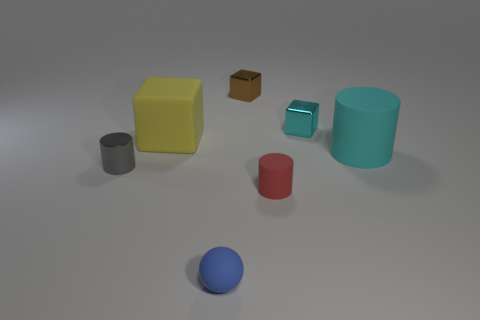There is a cyan object that is the same size as the red cylinder; what shape is it?
Your response must be concise. Cube. There is a cyan object in front of the large yellow cube; what number of red rubber cylinders are on the right side of it?
Your answer should be compact. 0. Is the color of the sphere the same as the big matte cylinder?
Keep it short and to the point. No. How many other objects are the same material as the brown object?
Provide a succinct answer. 2. What shape is the large object behind the cylinder that is behind the tiny gray metal cylinder?
Make the answer very short. Cube. What is the size of the block right of the small red thing?
Give a very brief answer. Small. Is the small gray cylinder made of the same material as the large yellow object?
Your answer should be very brief. No. The cyan object that is made of the same material as the gray thing is what shape?
Ensure brevity in your answer.  Cube. Are there any other things of the same color as the small rubber sphere?
Your answer should be compact. No. There is a object that is left of the big yellow thing; what color is it?
Ensure brevity in your answer.  Gray. 